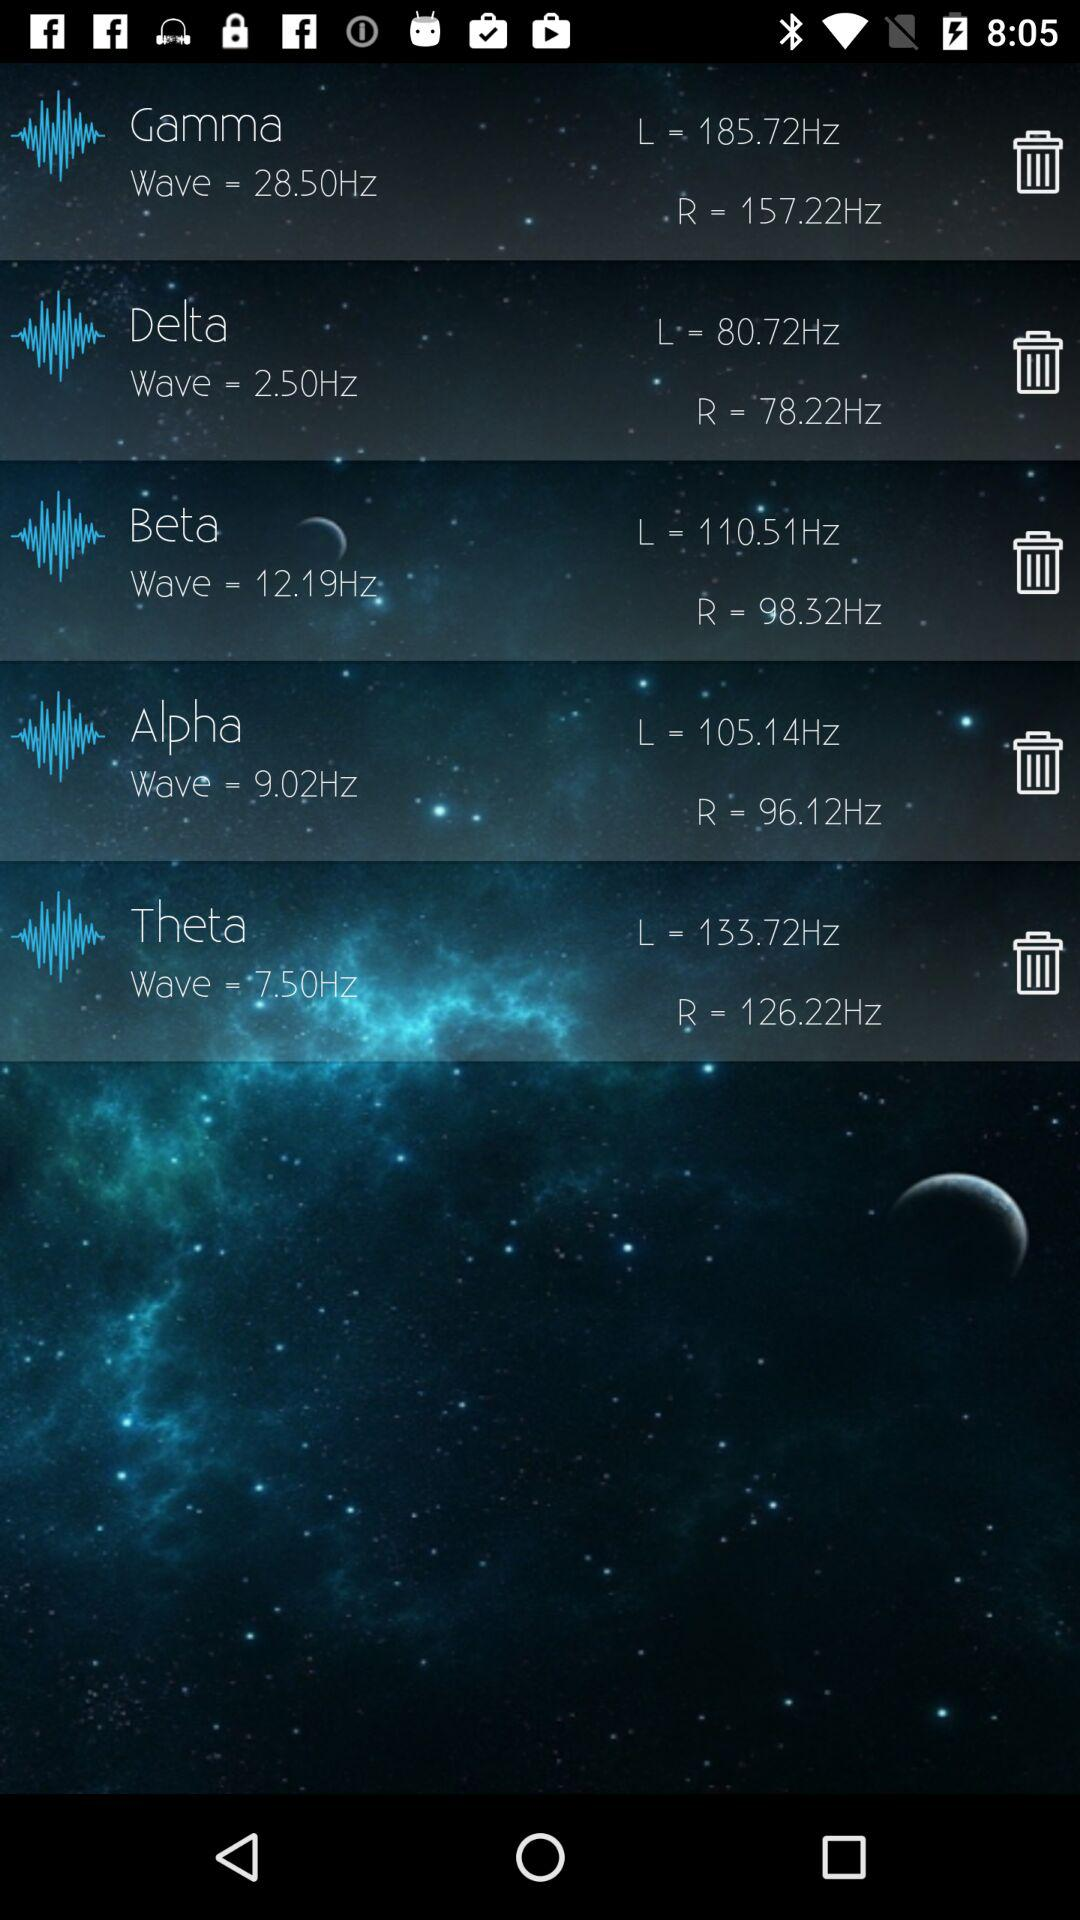What's the frequency of gamma? The frequency is 28.50 Hz. 